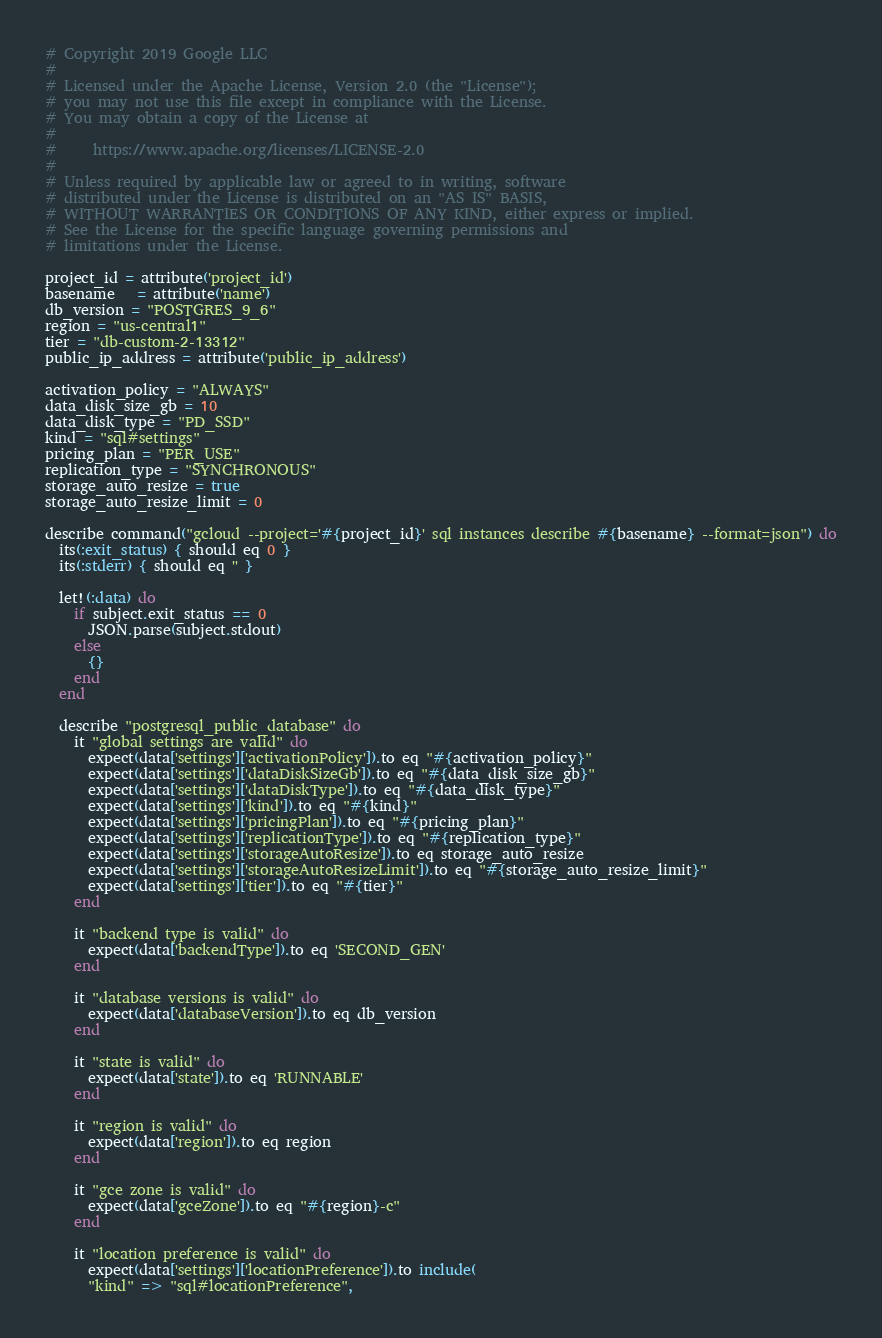<code> <loc_0><loc_0><loc_500><loc_500><_Ruby_># Copyright 2019 Google LLC
#
# Licensed under the Apache License, Version 2.0 (the "License");
# you may not use this file except in compliance with the License.
# You may obtain a copy of the License at
#
#     https://www.apache.org/licenses/LICENSE-2.0
#
# Unless required by applicable law or agreed to in writing, software
# distributed under the License is distributed on an "AS IS" BASIS,
# WITHOUT WARRANTIES OR CONDITIONS OF ANY KIND, either express or implied.
# See the License for the specific language governing permissions and
# limitations under the License.

project_id = attribute('project_id')
basename   = attribute('name')
db_version = "POSTGRES_9_6"
region = "us-central1"
tier = "db-custom-2-13312"
public_ip_address = attribute('public_ip_address')

activation_policy = "ALWAYS"
data_disk_size_gb = 10
data_disk_type = "PD_SSD"
kind = "sql#settings"
pricing_plan = "PER_USE"
replication_type = "SYNCHRONOUS"
storage_auto_resize = true
storage_auto_resize_limit = 0

describe command("gcloud --project='#{project_id}' sql instances describe #{basename} --format=json") do
  its(:exit_status) { should eq 0 }
  its(:stderr) { should eq '' }

  let!(:data) do
    if subject.exit_status == 0
      JSON.parse(subject.stdout)
    else
      {}
    end
  end

  describe "postgresql_public_database" do
    it "global settings are valid" do
      expect(data['settings']['activationPolicy']).to eq "#{activation_policy}"
      expect(data['settings']['dataDiskSizeGb']).to eq "#{data_disk_size_gb}"
      expect(data['settings']['dataDiskType']).to eq "#{data_disk_type}"
      expect(data['settings']['kind']).to eq "#{kind}"
      expect(data['settings']['pricingPlan']).to eq "#{pricing_plan}"
      expect(data['settings']['replicationType']).to eq "#{replication_type}"
      expect(data['settings']['storageAutoResize']).to eq storage_auto_resize
      expect(data['settings']['storageAutoResizeLimit']).to eq "#{storage_auto_resize_limit}"
      expect(data['settings']['tier']).to eq "#{tier}"
    end

    it "backend type is valid" do
      expect(data['backendType']).to eq 'SECOND_GEN'
    end

    it "database versions is valid" do
      expect(data['databaseVersion']).to eq db_version
    end

    it "state is valid" do
      expect(data['state']).to eq 'RUNNABLE'
    end

    it "region is valid" do
      expect(data['region']).to eq region
    end

    it "gce zone is valid" do
      expect(data['gceZone']).to eq "#{region}-c"
    end

    it "location preference is valid" do
      expect(data['settings']['locationPreference']).to include(
      "kind" => "sql#locationPreference",</code> 